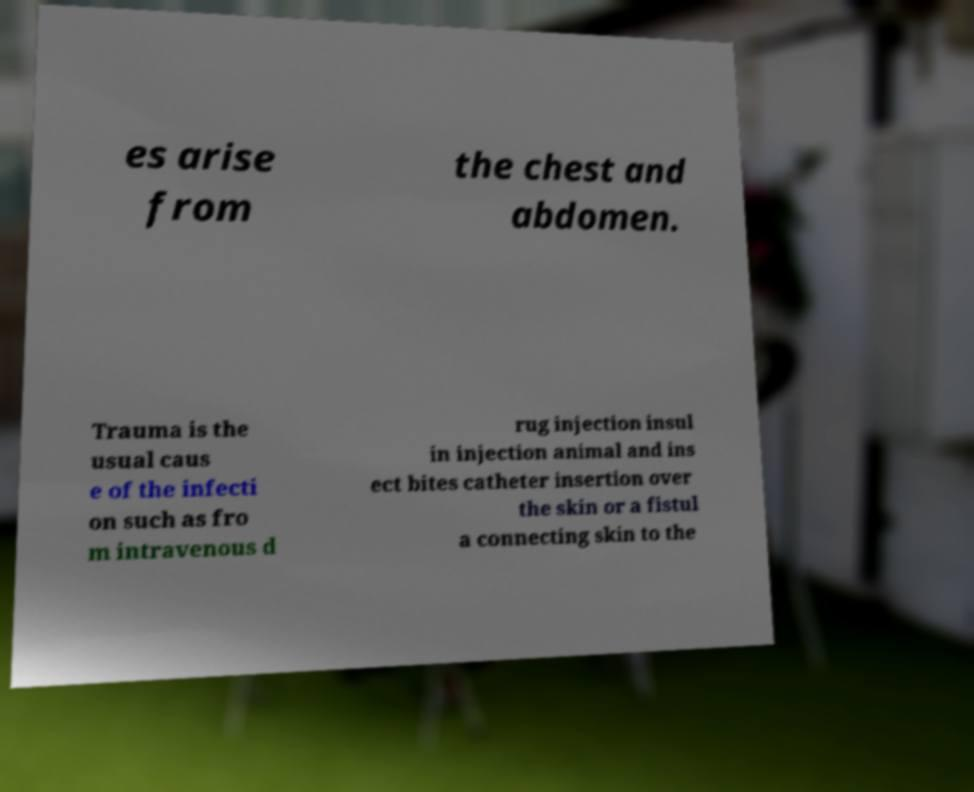Could you assist in decoding the text presented in this image and type it out clearly? es arise from the chest and abdomen. Trauma is the usual caus e of the infecti on such as fro m intravenous d rug injection insul in injection animal and ins ect bites catheter insertion over the skin or a fistul a connecting skin to the 